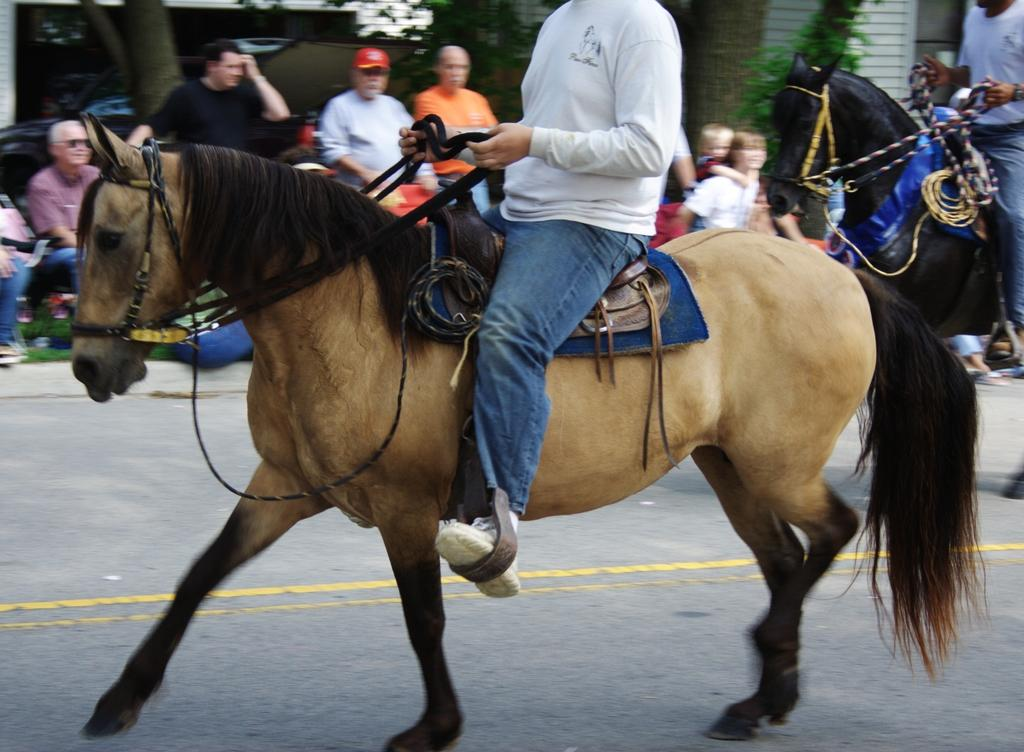What is the main subject of the image? There is a man riding a horse in the center of the image. Can you describe the background of the image? There are persons in the background of the image. Are there any other horse riders in the image? Yes, there is a man riding a black horse on the right side of the image. How many ants can be seen on the horse in the image? There are no ants visible on the horse in the image. What type of mice are interacting with the horse riders in the image? There are no mice present in the image. 